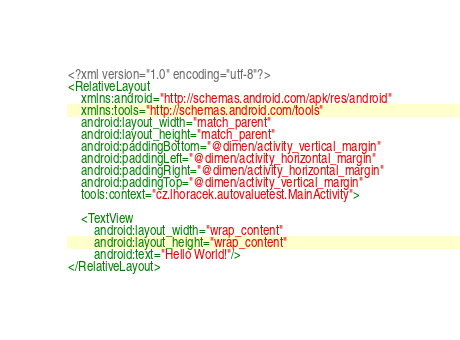Convert code to text. <code><loc_0><loc_0><loc_500><loc_500><_XML_><?xml version="1.0" encoding="utf-8"?>
<RelativeLayout
    xmlns:android="http://schemas.android.com/apk/res/android"
    xmlns:tools="http://schemas.android.com/tools"
    android:layout_width="match_parent"
    android:layout_height="match_parent"
    android:paddingBottom="@dimen/activity_vertical_margin"
    android:paddingLeft="@dimen/activity_horizontal_margin"
    android:paddingRight="@dimen/activity_horizontal_margin"
    android:paddingTop="@dimen/activity_vertical_margin"
    tools:context="cz.lhoracek.autovaluetest.MainActivity">

    <TextView
        android:layout_width="wrap_content"
        android:layout_height="wrap_content"
        android:text="Hello World!"/>
</RelativeLayout>
</code> 